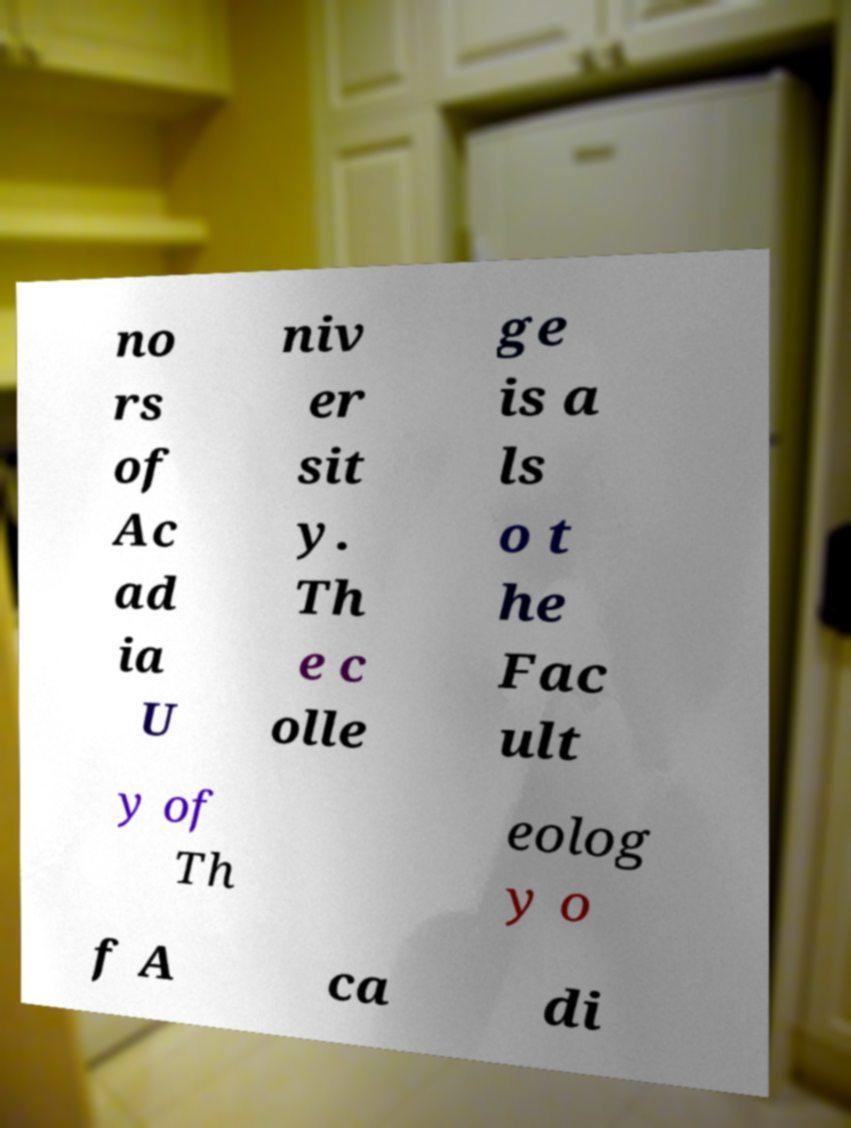There's text embedded in this image that I need extracted. Can you transcribe it verbatim? no rs of Ac ad ia U niv er sit y. Th e c olle ge is a ls o t he Fac ult y of Th eolog y o f A ca di 